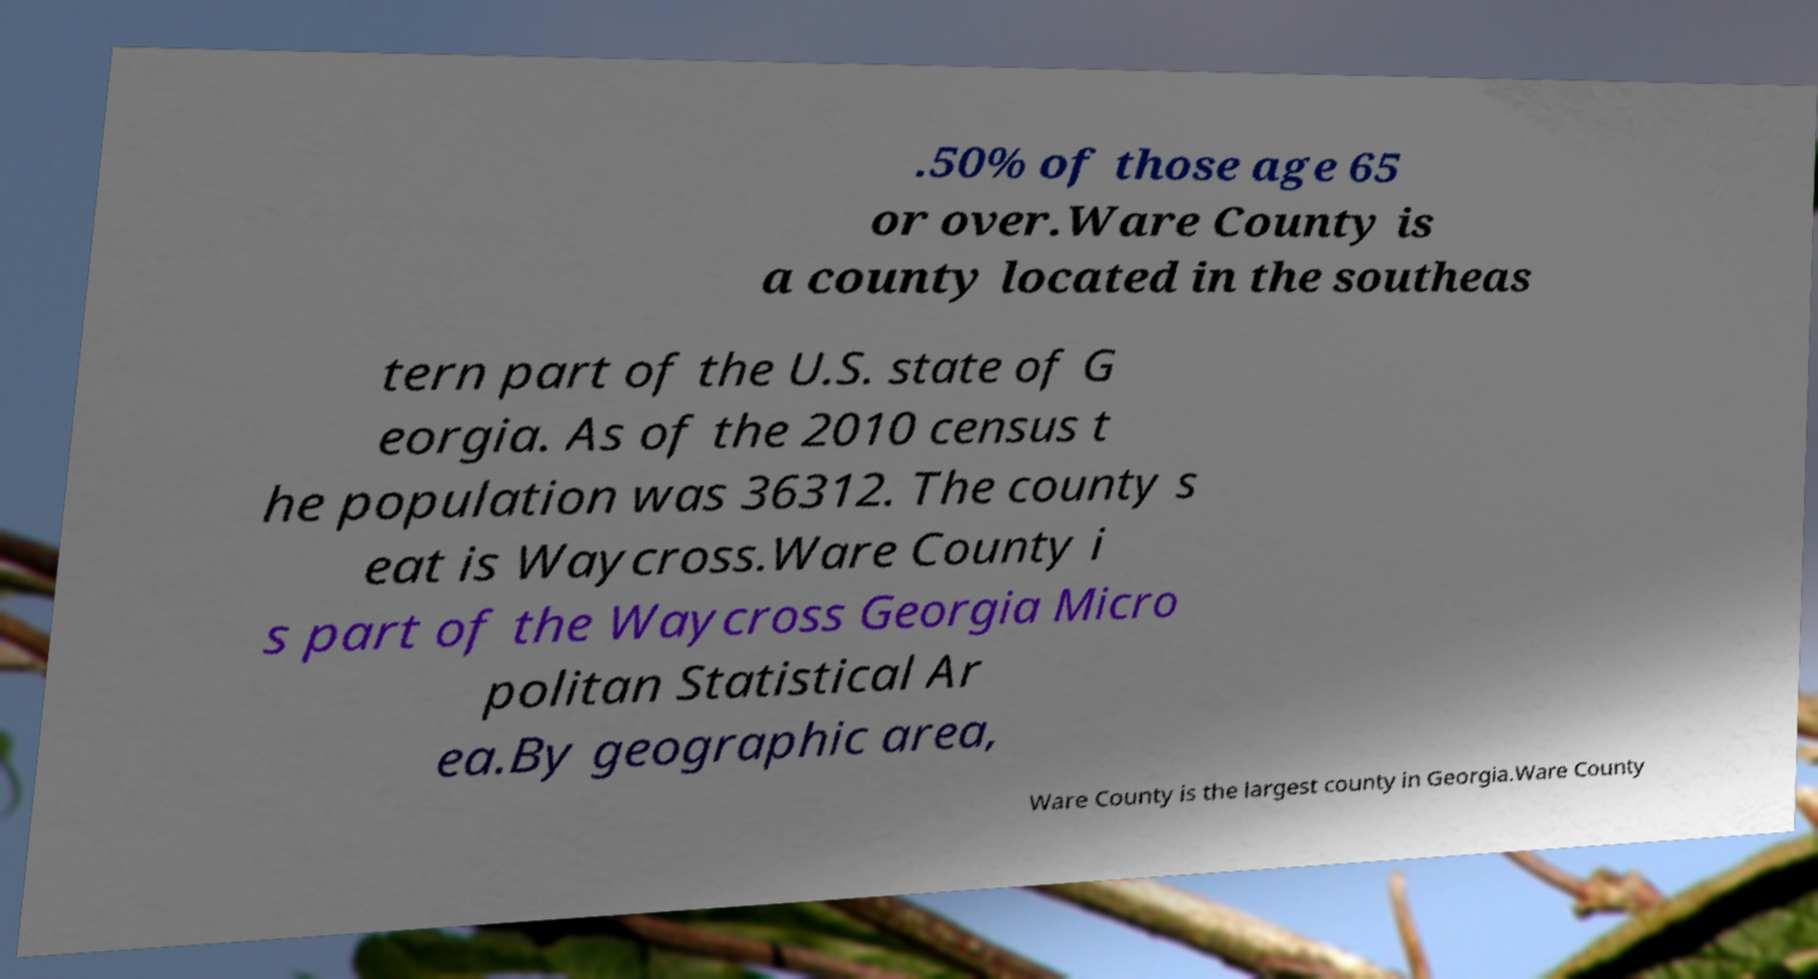Can you read and provide the text displayed in the image?This photo seems to have some interesting text. Can you extract and type it out for me? .50% of those age 65 or over.Ware County is a county located in the southeas tern part of the U.S. state of G eorgia. As of the 2010 census t he population was 36312. The county s eat is Waycross.Ware County i s part of the Waycross Georgia Micro politan Statistical Ar ea.By geographic area, Ware County is the largest county in Georgia.Ware County 